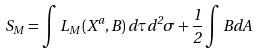<formula> <loc_0><loc_0><loc_500><loc_500>S _ { M } = \int L _ { M } \left ( X ^ { a } , B \right ) d \tau d ^ { 2 } \sigma + \frac { 1 } { 2 } \int B d A</formula> 